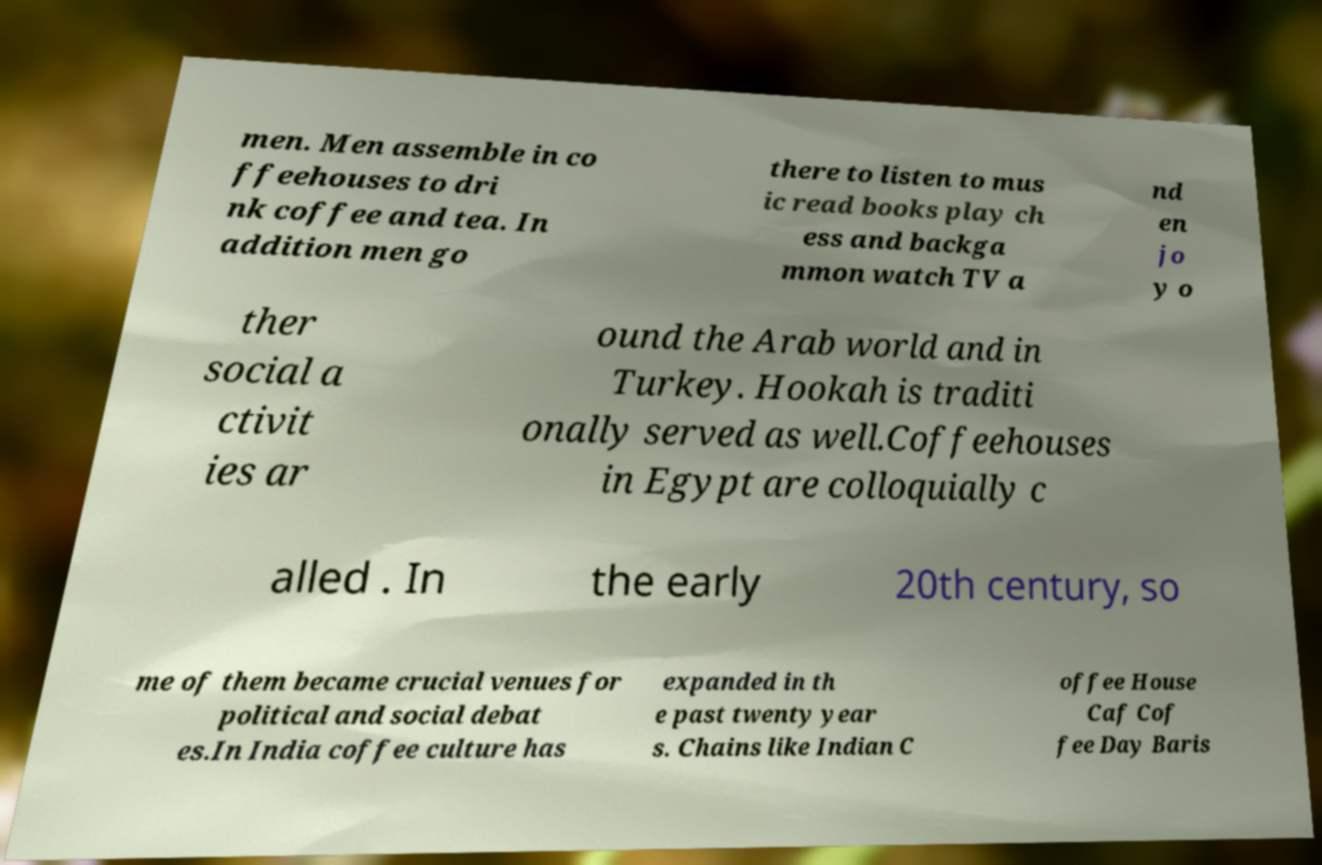There's text embedded in this image that I need extracted. Can you transcribe it verbatim? men. Men assemble in co ffeehouses to dri nk coffee and tea. In addition men go there to listen to mus ic read books play ch ess and backga mmon watch TV a nd en jo y o ther social a ctivit ies ar ound the Arab world and in Turkey. Hookah is traditi onally served as well.Coffeehouses in Egypt are colloquially c alled . In the early 20th century, so me of them became crucial venues for political and social debat es.In India coffee culture has expanded in th e past twenty year s. Chains like Indian C offee House Caf Cof fee Day Baris 